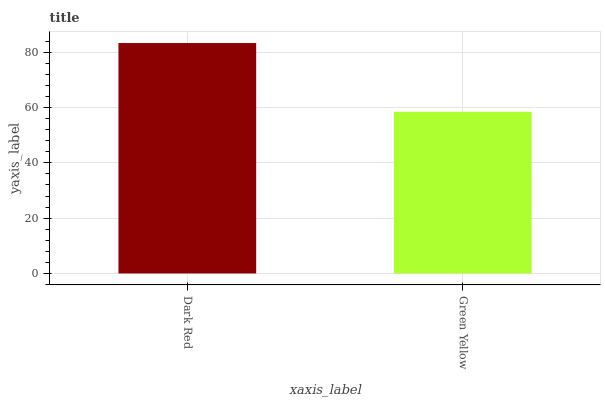Is Green Yellow the minimum?
Answer yes or no. Yes. Is Dark Red the maximum?
Answer yes or no. Yes. Is Green Yellow the maximum?
Answer yes or no. No. Is Dark Red greater than Green Yellow?
Answer yes or no. Yes. Is Green Yellow less than Dark Red?
Answer yes or no. Yes. Is Green Yellow greater than Dark Red?
Answer yes or no. No. Is Dark Red less than Green Yellow?
Answer yes or no. No. Is Dark Red the high median?
Answer yes or no. Yes. Is Green Yellow the low median?
Answer yes or no. Yes. Is Green Yellow the high median?
Answer yes or no. No. Is Dark Red the low median?
Answer yes or no. No. 